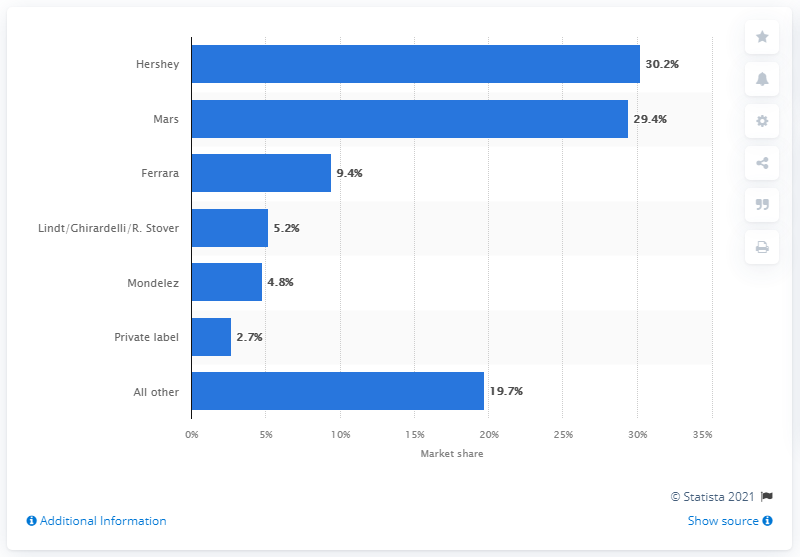Highlight a few significant elements in this photo. In 2018, Hershey's share of the confectionery market was 30.2%. In 2018, Hershey's primary competitor in the confectionery market was Mars. 